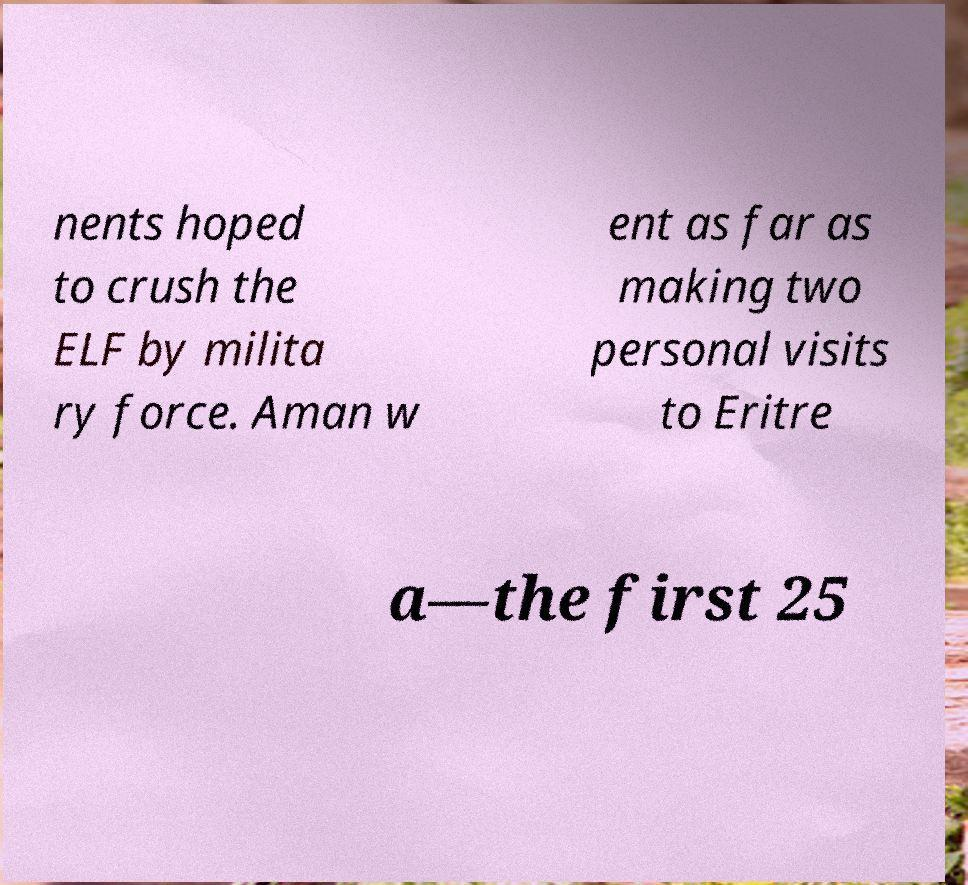I need the written content from this picture converted into text. Can you do that? nents hoped to crush the ELF by milita ry force. Aman w ent as far as making two personal visits to Eritre a—the first 25 